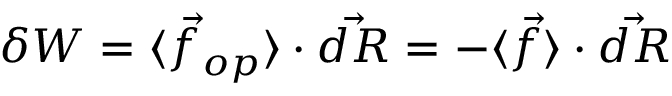<formula> <loc_0><loc_0><loc_500><loc_500>\delta W = \langle { \vec { f } } _ { o p } \rangle \cdot { \vec { d R } } = - \langle { \vec { f } } \rangle \cdot { \vec { d R } }</formula> 